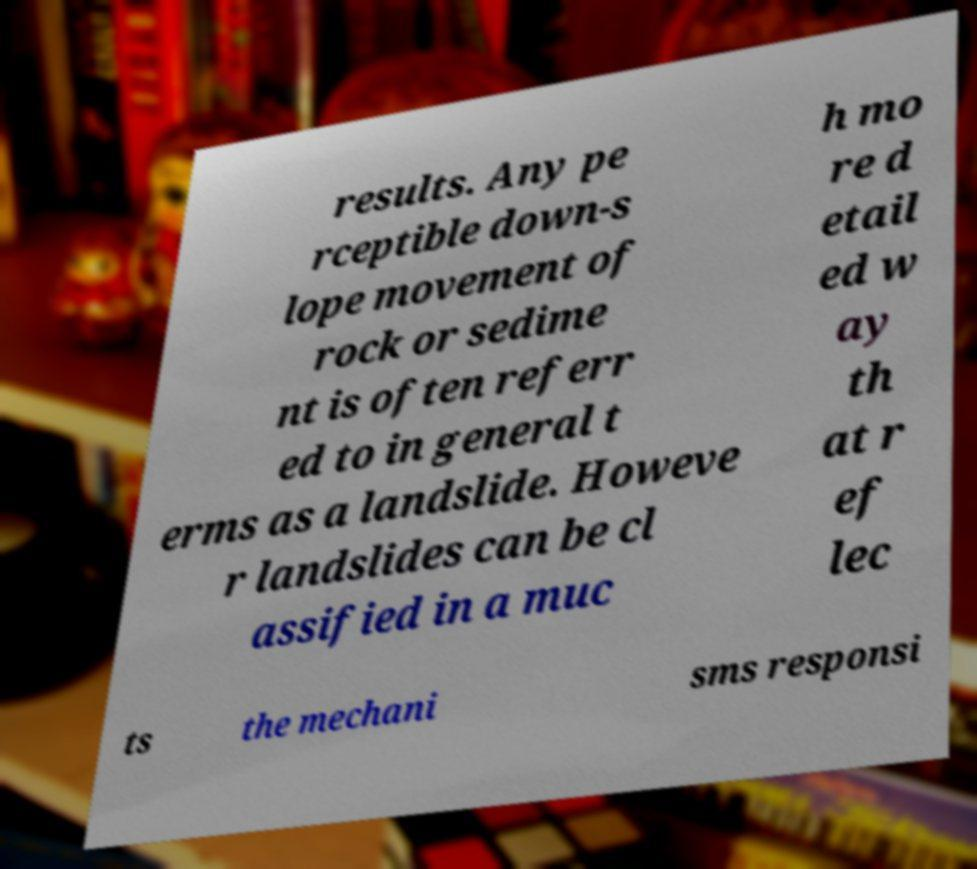Can you read and provide the text displayed in the image?This photo seems to have some interesting text. Can you extract and type it out for me? results. Any pe rceptible down-s lope movement of rock or sedime nt is often referr ed to in general t erms as a landslide. Howeve r landslides can be cl assified in a muc h mo re d etail ed w ay th at r ef lec ts the mechani sms responsi 